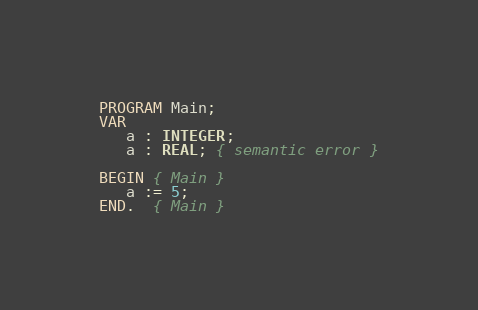<code> <loc_0><loc_0><loc_500><loc_500><_Pascal_>PROGRAM Main;
VAR
   a : INTEGER;
   a : REAL; { semantic error }

BEGIN { Main }
   a := 5;
END.  { Main }</code> 